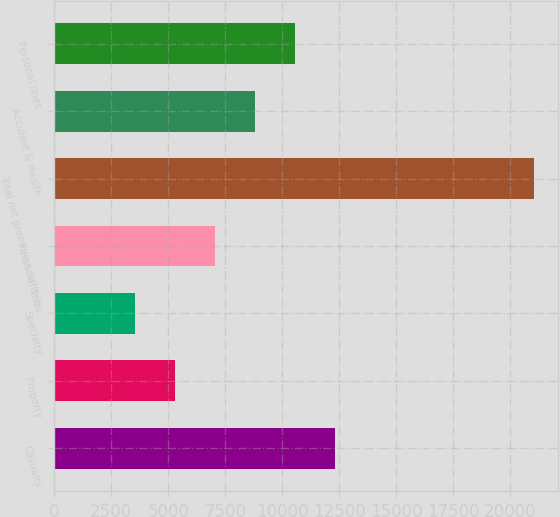<chart> <loc_0><loc_0><loc_500><loc_500><bar_chart><fcel>Casualty<fcel>Property<fcel>Specialty<fcel>Financial lines<fcel>Total net premiums written<fcel>Accident & Health<fcel>Personal lines<nl><fcel>12303.5<fcel>5302.3<fcel>3552<fcel>7052.6<fcel>21055<fcel>8802.9<fcel>10553.2<nl></chart> 